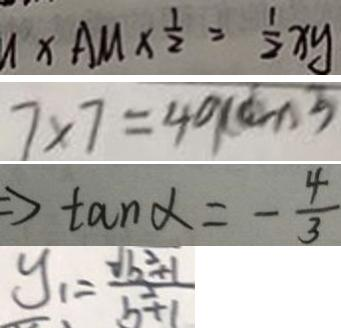<formula> <loc_0><loc_0><loc_500><loc_500>x A M \times \frac { 1 } { 2 } = \frac { 1 } { 2 } x y 
 7 \times 7 = 4 9 ( c m ^ { 2 } ) 
 \Rightarrow \tan \alpha = - \frac { 4 } { 3 } 
 y _ { 1 } = \frac { \sqrt { b ^ { 2 } + 1 } } { b ^ { 2 } + 1 }</formula> 